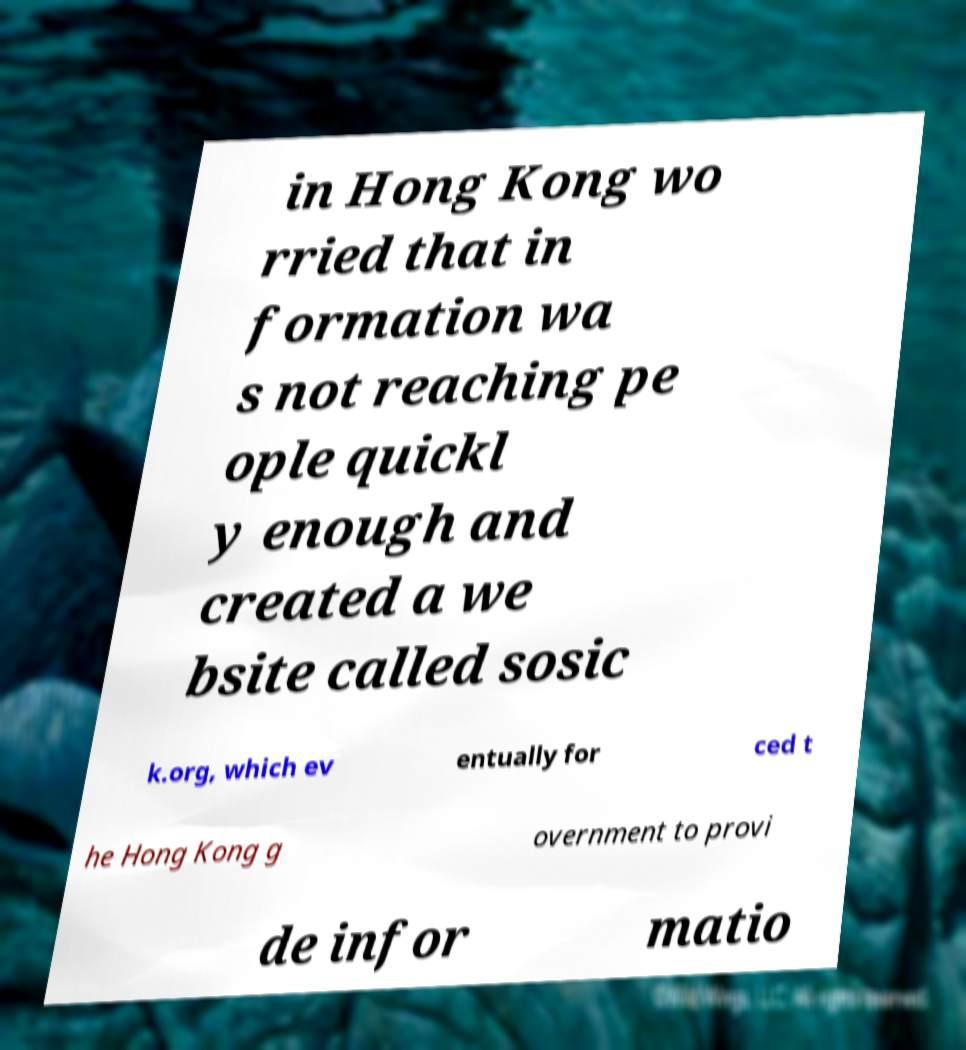Please identify and transcribe the text found in this image. in Hong Kong wo rried that in formation wa s not reaching pe ople quickl y enough and created a we bsite called sosic k.org, which ev entually for ced t he Hong Kong g overnment to provi de infor matio 